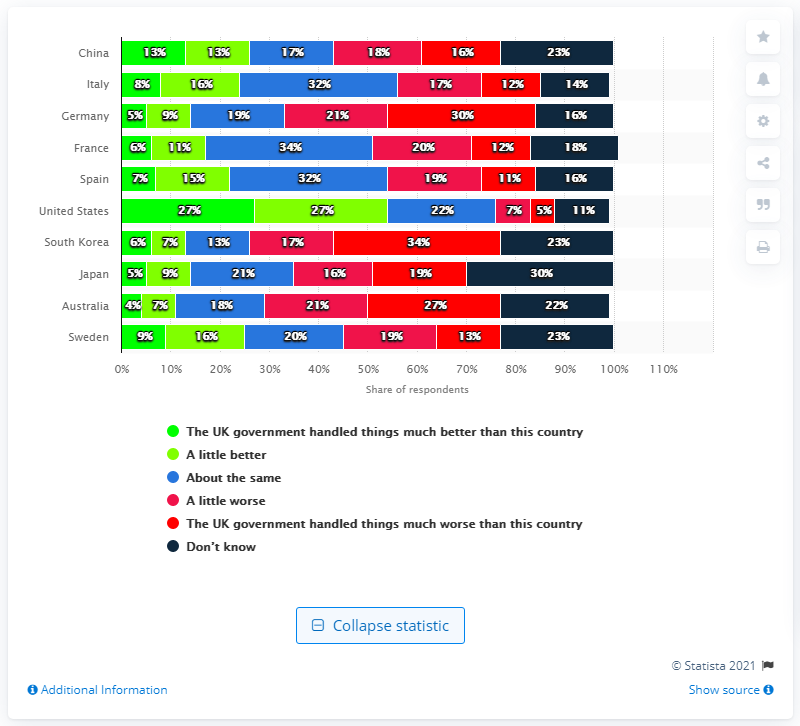Give some essential details in this illustration. The UK carried out a survey in May 2020, which showed that the coronavirus pandemic was effectively managed in Germany. 